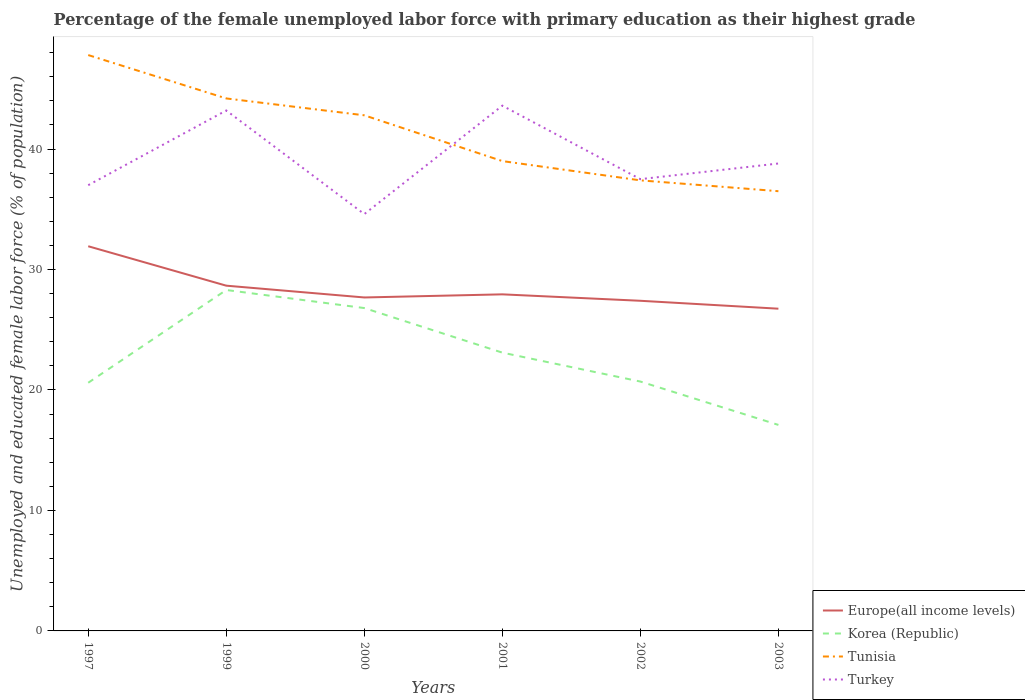How many different coloured lines are there?
Your answer should be compact. 4. Is the number of lines equal to the number of legend labels?
Give a very brief answer. Yes. Across all years, what is the maximum percentage of the unemployed female labor force with primary education in Tunisia?
Your answer should be very brief. 36.5. What is the total percentage of the unemployed female labor force with primary education in Europe(all income levels) in the graph?
Give a very brief answer. 3.27. How many years are there in the graph?
Make the answer very short. 6. Where does the legend appear in the graph?
Provide a succinct answer. Bottom right. How are the legend labels stacked?
Make the answer very short. Vertical. What is the title of the graph?
Ensure brevity in your answer.  Percentage of the female unemployed labor force with primary education as their highest grade. What is the label or title of the Y-axis?
Offer a terse response. Unemployed and educated female labor force (% of population). What is the Unemployed and educated female labor force (% of population) in Europe(all income levels) in 1997?
Your answer should be very brief. 31.93. What is the Unemployed and educated female labor force (% of population) of Korea (Republic) in 1997?
Offer a very short reply. 20.6. What is the Unemployed and educated female labor force (% of population) of Tunisia in 1997?
Offer a very short reply. 47.8. What is the Unemployed and educated female labor force (% of population) of Europe(all income levels) in 1999?
Provide a short and direct response. 28.66. What is the Unemployed and educated female labor force (% of population) in Korea (Republic) in 1999?
Your answer should be compact. 28.3. What is the Unemployed and educated female labor force (% of population) in Tunisia in 1999?
Keep it short and to the point. 44.2. What is the Unemployed and educated female labor force (% of population) of Turkey in 1999?
Offer a terse response. 43.2. What is the Unemployed and educated female labor force (% of population) in Europe(all income levels) in 2000?
Make the answer very short. 27.68. What is the Unemployed and educated female labor force (% of population) of Korea (Republic) in 2000?
Offer a terse response. 26.8. What is the Unemployed and educated female labor force (% of population) of Tunisia in 2000?
Give a very brief answer. 42.8. What is the Unemployed and educated female labor force (% of population) in Turkey in 2000?
Offer a very short reply. 34.6. What is the Unemployed and educated female labor force (% of population) in Europe(all income levels) in 2001?
Offer a terse response. 27.94. What is the Unemployed and educated female labor force (% of population) in Korea (Republic) in 2001?
Provide a short and direct response. 23.1. What is the Unemployed and educated female labor force (% of population) of Turkey in 2001?
Offer a very short reply. 43.6. What is the Unemployed and educated female labor force (% of population) of Europe(all income levels) in 2002?
Your response must be concise. 27.4. What is the Unemployed and educated female labor force (% of population) of Korea (Republic) in 2002?
Ensure brevity in your answer.  20.7. What is the Unemployed and educated female labor force (% of population) of Tunisia in 2002?
Give a very brief answer. 37.4. What is the Unemployed and educated female labor force (% of population) in Turkey in 2002?
Your response must be concise. 37.5. What is the Unemployed and educated female labor force (% of population) in Europe(all income levels) in 2003?
Offer a very short reply. 26.75. What is the Unemployed and educated female labor force (% of population) in Korea (Republic) in 2003?
Make the answer very short. 17.1. What is the Unemployed and educated female labor force (% of population) in Tunisia in 2003?
Offer a very short reply. 36.5. What is the Unemployed and educated female labor force (% of population) of Turkey in 2003?
Ensure brevity in your answer.  38.8. Across all years, what is the maximum Unemployed and educated female labor force (% of population) of Europe(all income levels)?
Offer a very short reply. 31.93. Across all years, what is the maximum Unemployed and educated female labor force (% of population) in Korea (Republic)?
Keep it short and to the point. 28.3. Across all years, what is the maximum Unemployed and educated female labor force (% of population) of Tunisia?
Make the answer very short. 47.8. Across all years, what is the maximum Unemployed and educated female labor force (% of population) of Turkey?
Your answer should be very brief. 43.6. Across all years, what is the minimum Unemployed and educated female labor force (% of population) in Europe(all income levels)?
Offer a terse response. 26.75. Across all years, what is the minimum Unemployed and educated female labor force (% of population) of Korea (Republic)?
Your response must be concise. 17.1. Across all years, what is the minimum Unemployed and educated female labor force (% of population) of Tunisia?
Keep it short and to the point. 36.5. Across all years, what is the minimum Unemployed and educated female labor force (% of population) in Turkey?
Provide a short and direct response. 34.6. What is the total Unemployed and educated female labor force (% of population) in Europe(all income levels) in the graph?
Offer a very short reply. 170.36. What is the total Unemployed and educated female labor force (% of population) in Korea (Republic) in the graph?
Your answer should be compact. 136.6. What is the total Unemployed and educated female labor force (% of population) in Tunisia in the graph?
Give a very brief answer. 247.7. What is the total Unemployed and educated female labor force (% of population) of Turkey in the graph?
Give a very brief answer. 234.7. What is the difference between the Unemployed and educated female labor force (% of population) in Europe(all income levels) in 1997 and that in 1999?
Make the answer very short. 3.27. What is the difference between the Unemployed and educated female labor force (% of population) in Korea (Republic) in 1997 and that in 1999?
Keep it short and to the point. -7.7. What is the difference between the Unemployed and educated female labor force (% of population) in Tunisia in 1997 and that in 1999?
Your answer should be very brief. 3.6. What is the difference between the Unemployed and educated female labor force (% of population) in Europe(all income levels) in 1997 and that in 2000?
Offer a terse response. 4.25. What is the difference between the Unemployed and educated female labor force (% of population) in Korea (Republic) in 1997 and that in 2000?
Give a very brief answer. -6.2. What is the difference between the Unemployed and educated female labor force (% of population) in Turkey in 1997 and that in 2000?
Keep it short and to the point. 2.4. What is the difference between the Unemployed and educated female labor force (% of population) of Europe(all income levels) in 1997 and that in 2001?
Keep it short and to the point. 3.99. What is the difference between the Unemployed and educated female labor force (% of population) in Korea (Republic) in 1997 and that in 2001?
Make the answer very short. -2.5. What is the difference between the Unemployed and educated female labor force (% of population) of Tunisia in 1997 and that in 2001?
Your answer should be compact. 8.8. What is the difference between the Unemployed and educated female labor force (% of population) of Europe(all income levels) in 1997 and that in 2002?
Provide a short and direct response. 4.53. What is the difference between the Unemployed and educated female labor force (% of population) in Turkey in 1997 and that in 2002?
Give a very brief answer. -0.5. What is the difference between the Unemployed and educated female labor force (% of population) of Europe(all income levels) in 1997 and that in 2003?
Your answer should be very brief. 5.18. What is the difference between the Unemployed and educated female labor force (% of population) in Korea (Republic) in 1997 and that in 2003?
Keep it short and to the point. 3.5. What is the difference between the Unemployed and educated female labor force (% of population) of Tunisia in 1997 and that in 2003?
Offer a very short reply. 11.3. What is the difference between the Unemployed and educated female labor force (% of population) of Turkey in 1997 and that in 2003?
Your answer should be very brief. -1.8. What is the difference between the Unemployed and educated female labor force (% of population) in Europe(all income levels) in 1999 and that in 2000?
Make the answer very short. 0.98. What is the difference between the Unemployed and educated female labor force (% of population) in Turkey in 1999 and that in 2000?
Ensure brevity in your answer.  8.6. What is the difference between the Unemployed and educated female labor force (% of population) of Europe(all income levels) in 1999 and that in 2001?
Your answer should be compact. 0.72. What is the difference between the Unemployed and educated female labor force (% of population) in Turkey in 1999 and that in 2001?
Ensure brevity in your answer.  -0.4. What is the difference between the Unemployed and educated female labor force (% of population) in Europe(all income levels) in 1999 and that in 2002?
Your answer should be compact. 1.25. What is the difference between the Unemployed and educated female labor force (% of population) in Korea (Republic) in 1999 and that in 2002?
Your answer should be very brief. 7.6. What is the difference between the Unemployed and educated female labor force (% of population) of Tunisia in 1999 and that in 2002?
Ensure brevity in your answer.  6.8. What is the difference between the Unemployed and educated female labor force (% of population) of Turkey in 1999 and that in 2002?
Make the answer very short. 5.7. What is the difference between the Unemployed and educated female labor force (% of population) in Europe(all income levels) in 1999 and that in 2003?
Ensure brevity in your answer.  1.91. What is the difference between the Unemployed and educated female labor force (% of population) in Korea (Republic) in 1999 and that in 2003?
Your answer should be compact. 11.2. What is the difference between the Unemployed and educated female labor force (% of population) in Turkey in 1999 and that in 2003?
Provide a succinct answer. 4.4. What is the difference between the Unemployed and educated female labor force (% of population) of Europe(all income levels) in 2000 and that in 2001?
Make the answer very short. -0.26. What is the difference between the Unemployed and educated female labor force (% of population) of Korea (Republic) in 2000 and that in 2001?
Make the answer very short. 3.7. What is the difference between the Unemployed and educated female labor force (% of population) of Turkey in 2000 and that in 2001?
Keep it short and to the point. -9. What is the difference between the Unemployed and educated female labor force (% of population) in Europe(all income levels) in 2000 and that in 2002?
Your answer should be compact. 0.28. What is the difference between the Unemployed and educated female labor force (% of population) of Korea (Republic) in 2000 and that in 2002?
Your answer should be compact. 6.1. What is the difference between the Unemployed and educated female labor force (% of population) of Europe(all income levels) in 2000 and that in 2003?
Offer a terse response. 0.93. What is the difference between the Unemployed and educated female labor force (% of population) in Korea (Republic) in 2000 and that in 2003?
Keep it short and to the point. 9.7. What is the difference between the Unemployed and educated female labor force (% of population) of Tunisia in 2000 and that in 2003?
Provide a succinct answer. 6.3. What is the difference between the Unemployed and educated female labor force (% of population) in Europe(all income levels) in 2001 and that in 2002?
Provide a succinct answer. 0.53. What is the difference between the Unemployed and educated female labor force (% of population) in Korea (Republic) in 2001 and that in 2002?
Offer a very short reply. 2.4. What is the difference between the Unemployed and educated female labor force (% of population) of Europe(all income levels) in 2001 and that in 2003?
Your answer should be compact. 1.19. What is the difference between the Unemployed and educated female labor force (% of population) in Europe(all income levels) in 2002 and that in 2003?
Your answer should be compact. 0.66. What is the difference between the Unemployed and educated female labor force (% of population) of Turkey in 2002 and that in 2003?
Your answer should be compact. -1.3. What is the difference between the Unemployed and educated female labor force (% of population) of Europe(all income levels) in 1997 and the Unemployed and educated female labor force (% of population) of Korea (Republic) in 1999?
Offer a terse response. 3.63. What is the difference between the Unemployed and educated female labor force (% of population) of Europe(all income levels) in 1997 and the Unemployed and educated female labor force (% of population) of Tunisia in 1999?
Your answer should be compact. -12.27. What is the difference between the Unemployed and educated female labor force (% of population) in Europe(all income levels) in 1997 and the Unemployed and educated female labor force (% of population) in Turkey in 1999?
Your answer should be very brief. -11.27. What is the difference between the Unemployed and educated female labor force (% of population) in Korea (Republic) in 1997 and the Unemployed and educated female labor force (% of population) in Tunisia in 1999?
Ensure brevity in your answer.  -23.6. What is the difference between the Unemployed and educated female labor force (% of population) in Korea (Republic) in 1997 and the Unemployed and educated female labor force (% of population) in Turkey in 1999?
Ensure brevity in your answer.  -22.6. What is the difference between the Unemployed and educated female labor force (% of population) in Tunisia in 1997 and the Unemployed and educated female labor force (% of population) in Turkey in 1999?
Your answer should be very brief. 4.6. What is the difference between the Unemployed and educated female labor force (% of population) of Europe(all income levels) in 1997 and the Unemployed and educated female labor force (% of population) of Korea (Republic) in 2000?
Keep it short and to the point. 5.13. What is the difference between the Unemployed and educated female labor force (% of population) in Europe(all income levels) in 1997 and the Unemployed and educated female labor force (% of population) in Tunisia in 2000?
Make the answer very short. -10.87. What is the difference between the Unemployed and educated female labor force (% of population) of Europe(all income levels) in 1997 and the Unemployed and educated female labor force (% of population) of Turkey in 2000?
Your response must be concise. -2.67. What is the difference between the Unemployed and educated female labor force (% of population) in Korea (Republic) in 1997 and the Unemployed and educated female labor force (% of population) in Tunisia in 2000?
Your response must be concise. -22.2. What is the difference between the Unemployed and educated female labor force (% of population) of Europe(all income levels) in 1997 and the Unemployed and educated female labor force (% of population) of Korea (Republic) in 2001?
Offer a very short reply. 8.83. What is the difference between the Unemployed and educated female labor force (% of population) in Europe(all income levels) in 1997 and the Unemployed and educated female labor force (% of population) in Tunisia in 2001?
Give a very brief answer. -7.07. What is the difference between the Unemployed and educated female labor force (% of population) in Europe(all income levels) in 1997 and the Unemployed and educated female labor force (% of population) in Turkey in 2001?
Provide a short and direct response. -11.67. What is the difference between the Unemployed and educated female labor force (% of population) in Korea (Republic) in 1997 and the Unemployed and educated female labor force (% of population) in Tunisia in 2001?
Offer a very short reply. -18.4. What is the difference between the Unemployed and educated female labor force (% of population) in Europe(all income levels) in 1997 and the Unemployed and educated female labor force (% of population) in Korea (Republic) in 2002?
Ensure brevity in your answer.  11.23. What is the difference between the Unemployed and educated female labor force (% of population) in Europe(all income levels) in 1997 and the Unemployed and educated female labor force (% of population) in Tunisia in 2002?
Your response must be concise. -5.47. What is the difference between the Unemployed and educated female labor force (% of population) of Europe(all income levels) in 1997 and the Unemployed and educated female labor force (% of population) of Turkey in 2002?
Offer a very short reply. -5.57. What is the difference between the Unemployed and educated female labor force (% of population) in Korea (Republic) in 1997 and the Unemployed and educated female labor force (% of population) in Tunisia in 2002?
Your answer should be compact. -16.8. What is the difference between the Unemployed and educated female labor force (% of population) in Korea (Republic) in 1997 and the Unemployed and educated female labor force (% of population) in Turkey in 2002?
Ensure brevity in your answer.  -16.9. What is the difference between the Unemployed and educated female labor force (% of population) of Europe(all income levels) in 1997 and the Unemployed and educated female labor force (% of population) of Korea (Republic) in 2003?
Give a very brief answer. 14.83. What is the difference between the Unemployed and educated female labor force (% of population) in Europe(all income levels) in 1997 and the Unemployed and educated female labor force (% of population) in Tunisia in 2003?
Offer a terse response. -4.57. What is the difference between the Unemployed and educated female labor force (% of population) in Europe(all income levels) in 1997 and the Unemployed and educated female labor force (% of population) in Turkey in 2003?
Provide a succinct answer. -6.87. What is the difference between the Unemployed and educated female labor force (% of population) in Korea (Republic) in 1997 and the Unemployed and educated female labor force (% of population) in Tunisia in 2003?
Provide a succinct answer. -15.9. What is the difference between the Unemployed and educated female labor force (% of population) of Korea (Republic) in 1997 and the Unemployed and educated female labor force (% of population) of Turkey in 2003?
Provide a succinct answer. -18.2. What is the difference between the Unemployed and educated female labor force (% of population) of Tunisia in 1997 and the Unemployed and educated female labor force (% of population) of Turkey in 2003?
Provide a short and direct response. 9. What is the difference between the Unemployed and educated female labor force (% of population) of Europe(all income levels) in 1999 and the Unemployed and educated female labor force (% of population) of Korea (Republic) in 2000?
Offer a terse response. 1.86. What is the difference between the Unemployed and educated female labor force (% of population) in Europe(all income levels) in 1999 and the Unemployed and educated female labor force (% of population) in Tunisia in 2000?
Make the answer very short. -14.14. What is the difference between the Unemployed and educated female labor force (% of population) of Europe(all income levels) in 1999 and the Unemployed and educated female labor force (% of population) of Turkey in 2000?
Make the answer very short. -5.94. What is the difference between the Unemployed and educated female labor force (% of population) in Europe(all income levels) in 1999 and the Unemployed and educated female labor force (% of population) in Korea (Republic) in 2001?
Offer a terse response. 5.56. What is the difference between the Unemployed and educated female labor force (% of population) in Europe(all income levels) in 1999 and the Unemployed and educated female labor force (% of population) in Tunisia in 2001?
Make the answer very short. -10.34. What is the difference between the Unemployed and educated female labor force (% of population) of Europe(all income levels) in 1999 and the Unemployed and educated female labor force (% of population) of Turkey in 2001?
Give a very brief answer. -14.94. What is the difference between the Unemployed and educated female labor force (% of population) in Korea (Republic) in 1999 and the Unemployed and educated female labor force (% of population) in Turkey in 2001?
Provide a succinct answer. -15.3. What is the difference between the Unemployed and educated female labor force (% of population) of Europe(all income levels) in 1999 and the Unemployed and educated female labor force (% of population) of Korea (Republic) in 2002?
Your answer should be very brief. 7.96. What is the difference between the Unemployed and educated female labor force (% of population) of Europe(all income levels) in 1999 and the Unemployed and educated female labor force (% of population) of Tunisia in 2002?
Your answer should be very brief. -8.74. What is the difference between the Unemployed and educated female labor force (% of population) of Europe(all income levels) in 1999 and the Unemployed and educated female labor force (% of population) of Turkey in 2002?
Give a very brief answer. -8.84. What is the difference between the Unemployed and educated female labor force (% of population) in Korea (Republic) in 1999 and the Unemployed and educated female labor force (% of population) in Tunisia in 2002?
Give a very brief answer. -9.1. What is the difference between the Unemployed and educated female labor force (% of population) of Europe(all income levels) in 1999 and the Unemployed and educated female labor force (% of population) of Korea (Republic) in 2003?
Offer a terse response. 11.56. What is the difference between the Unemployed and educated female labor force (% of population) in Europe(all income levels) in 1999 and the Unemployed and educated female labor force (% of population) in Tunisia in 2003?
Provide a short and direct response. -7.84. What is the difference between the Unemployed and educated female labor force (% of population) in Europe(all income levels) in 1999 and the Unemployed and educated female labor force (% of population) in Turkey in 2003?
Provide a short and direct response. -10.14. What is the difference between the Unemployed and educated female labor force (% of population) in Korea (Republic) in 1999 and the Unemployed and educated female labor force (% of population) in Turkey in 2003?
Provide a succinct answer. -10.5. What is the difference between the Unemployed and educated female labor force (% of population) of Tunisia in 1999 and the Unemployed and educated female labor force (% of population) of Turkey in 2003?
Provide a short and direct response. 5.4. What is the difference between the Unemployed and educated female labor force (% of population) in Europe(all income levels) in 2000 and the Unemployed and educated female labor force (% of population) in Korea (Republic) in 2001?
Offer a terse response. 4.58. What is the difference between the Unemployed and educated female labor force (% of population) of Europe(all income levels) in 2000 and the Unemployed and educated female labor force (% of population) of Tunisia in 2001?
Ensure brevity in your answer.  -11.32. What is the difference between the Unemployed and educated female labor force (% of population) of Europe(all income levels) in 2000 and the Unemployed and educated female labor force (% of population) of Turkey in 2001?
Provide a short and direct response. -15.92. What is the difference between the Unemployed and educated female labor force (% of population) in Korea (Republic) in 2000 and the Unemployed and educated female labor force (% of population) in Tunisia in 2001?
Your response must be concise. -12.2. What is the difference between the Unemployed and educated female labor force (% of population) in Korea (Republic) in 2000 and the Unemployed and educated female labor force (% of population) in Turkey in 2001?
Your answer should be compact. -16.8. What is the difference between the Unemployed and educated female labor force (% of population) of Tunisia in 2000 and the Unemployed and educated female labor force (% of population) of Turkey in 2001?
Your answer should be compact. -0.8. What is the difference between the Unemployed and educated female labor force (% of population) of Europe(all income levels) in 2000 and the Unemployed and educated female labor force (% of population) of Korea (Republic) in 2002?
Your answer should be compact. 6.98. What is the difference between the Unemployed and educated female labor force (% of population) of Europe(all income levels) in 2000 and the Unemployed and educated female labor force (% of population) of Tunisia in 2002?
Give a very brief answer. -9.72. What is the difference between the Unemployed and educated female labor force (% of population) of Europe(all income levels) in 2000 and the Unemployed and educated female labor force (% of population) of Turkey in 2002?
Your response must be concise. -9.82. What is the difference between the Unemployed and educated female labor force (% of population) of Korea (Republic) in 2000 and the Unemployed and educated female labor force (% of population) of Turkey in 2002?
Your response must be concise. -10.7. What is the difference between the Unemployed and educated female labor force (% of population) of Tunisia in 2000 and the Unemployed and educated female labor force (% of population) of Turkey in 2002?
Make the answer very short. 5.3. What is the difference between the Unemployed and educated female labor force (% of population) of Europe(all income levels) in 2000 and the Unemployed and educated female labor force (% of population) of Korea (Republic) in 2003?
Provide a short and direct response. 10.58. What is the difference between the Unemployed and educated female labor force (% of population) of Europe(all income levels) in 2000 and the Unemployed and educated female labor force (% of population) of Tunisia in 2003?
Your answer should be very brief. -8.82. What is the difference between the Unemployed and educated female labor force (% of population) of Europe(all income levels) in 2000 and the Unemployed and educated female labor force (% of population) of Turkey in 2003?
Your response must be concise. -11.12. What is the difference between the Unemployed and educated female labor force (% of population) in Korea (Republic) in 2000 and the Unemployed and educated female labor force (% of population) in Turkey in 2003?
Keep it short and to the point. -12. What is the difference between the Unemployed and educated female labor force (% of population) of Europe(all income levels) in 2001 and the Unemployed and educated female labor force (% of population) of Korea (Republic) in 2002?
Give a very brief answer. 7.24. What is the difference between the Unemployed and educated female labor force (% of population) of Europe(all income levels) in 2001 and the Unemployed and educated female labor force (% of population) of Tunisia in 2002?
Your answer should be very brief. -9.46. What is the difference between the Unemployed and educated female labor force (% of population) of Europe(all income levels) in 2001 and the Unemployed and educated female labor force (% of population) of Turkey in 2002?
Provide a short and direct response. -9.56. What is the difference between the Unemployed and educated female labor force (% of population) in Korea (Republic) in 2001 and the Unemployed and educated female labor force (% of population) in Tunisia in 2002?
Your answer should be very brief. -14.3. What is the difference between the Unemployed and educated female labor force (% of population) in Korea (Republic) in 2001 and the Unemployed and educated female labor force (% of population) in Turkey in 2002?
Give a very brief answer. -14.4. What is the difference between the Unemployed and educated female labor force (% of population) of Europe(all income levels) in 2001 and the Unemployed and educated female labor force (% of population) of Korea (Republic) in 2003?
Provide a succinct answer. 10.84. What is the difference between the Unemployed and educated female labor force (% of population) of Europe(all income levels) in 2001 and the Unemployed and educated female labor force (% of population) of Tunisia in 2003?
Provide a succinct answer. -8.56. What is the difference between the Unemployed and educated female labor force (% of population) in Europe(all income levels) in 2001 and the Unemployed and educated female labor force (% of population) in Turkey in 2003?
Provide a succinct answer. -10.86. What is the difference between the Unemployed and educated female labor force (% of population) of Korea (Republic) in 2001 and the Unemployed and educated female labor force (% of population) of Tunisia in 2003?
Offer a very short reply. -13.4. What is the difference between the Unemployed and educated female labor force (% of population) of Korea (Republic) in 2001 and the Unemployed and educated female labor force (% of population) of Turkey in 2003?
Make the answer very short. -15.7. What is the difference between the Unemployed and educated female labor force (% of population) of Tunisia in 2001 and the Unemployed and educated female labor force (% of population) of Turkey in 2003?
Make the answer very short. 0.2. What is the difference between the Unemployed and educated female labor force (% of population) of Europe(all income levels) in 2002 and the Unemployed and educated female labor force (% of population) of Korea (Republic) in 2003?
Provide a short and direct response. 10.3. What is the difference between the Unemployed and educated female labor force (% of population) of Europe(all income levels) in 2002 and the Unemployed and educated female labor force (% of population) of Tunisia in 2003?
Keep it short and to the point. -9.1. What is the difference between the Unemployed and educated female labor force (% of population) of Europe(all income levels) in 2002 and the Unemployed and educated female labor force (% of population) of Turkey in 2003?
Offer a very short reply. -11.4. What is the difference between the Unemployed and educated female labor force (% of population) in Korea (Republic) in 2002 and the Unemployed and educated female labor force (% of population) in Tunisia in 2003?
Provide a short and direct response. -15.8. What is the difference between the Unemployed and educated female labor force (% of population) of Korea (Republic) in 2002 and the Unemployed and educated female labor force (% of population) of Turkey in 2003?
Your answer should be very brief. -18.1. What is the average Unemployed and educated female labor force (% of population) in Europe(all income levels) per year?
Give a very brief answer. 28.39. What is the average Unemployed and educated female labor force (% of population) of Korea (Republic) per year?
Ensure brevity in your answer.  22.77. What is the average Unemployed and educated female labor force (% of population) of Tunisia per year?
Offer a terse response. 41.28. What is the average Unemployed and educated female labor force (% of population) of Turkey per year?
Your answer should be compact. 39.12. In the year 1997, what is the difference between the Unemployed and educated female labor force (% of population) of Europe(all income levels) and Unemployed and educated female labor force (% of population) of Korea (Republic)?
Make the answer very short. 11.33. In the year 1997, what is the difference between the Unemployed and educated female labor force (% of population) of Europe(all income levels) and Unemployed and educated female labor force (% of population) of Tunisia?
Provide a short and direct response. -15.87. In the year 1997, what is the difference between the Unemployed and educated female labor force (% of population) of Europe(all income levels) and Unemployed and educated female labor force (% of population) of Turkey?
Your answer should be very brief. -5.07. In the year 1997, what is the difference between the Unemployed and educated female labor force (% of population) in Korea (Republic) and Unemployed and educated female labor force (% of population) in Tunisia?
Give a very brief answer. -27.2. In the year 1997, what is the difference between the Unemployed and educated female labor force (% of population) of Korea (Republic) and Unemployed and educated female labor force (% of population) of Turkey?
Ensure brevity in your answer.  -16.4. In the year 1999, what is the difference between the Unemployed and educated female labor force (% of population) in Europe(all income levels) and Unemployed and educated female labor force (% of population) in Korea (Republic)?
Offer a very short reply. 0.36. In the year 1999, what is the difference between the Unemployed and educated female labor force (% of population) of Europe(all income levels) and Unemployed and educated female labor force (% of population) of Tunisia?
Ensure brevity in your answer.  -15.54. In the year 1999, what is the difference between the Unemployed and educated female labor force (% of population) in Europe(all income levels) and Unemployed and educated female labor force (% of population) in Turkey?
Make the answer very short. -14.54. In the year 1999, what is the difference between the Unemployed and educated female labor force (% of population) in Korea (Republic) and Unemployed and educated female labor force (% of population) in Tunisia?
Offer a very short reply. -15.9. In the year 1999, what is the difference between the Unemployed and educated female labor force (% of population) in Korea (Republic) and Unemployed and educated female labor force (% of population) in Turkey?
Provide a short and direct response. -14.9. In the year 2000, what is the difference between the Unemployed and educated female labor force (% of population) of Europe(all income levels) and Unemployed and educated female labor force (% of population) of Korea (Republic)?
Offer a terse response. 0.88. In the year 2000, what is the difference between the Unemployed and educated female labor force (% of population) in Europe(all income levels) and Unemployed and educated female labor force (% of population) in Tunisia?
Offer a very short reply. -15.12. In the year 2000, what is the difference between the Unemployed and educated female labor force (% of population) of Europe(all income levels) and Unemployed and educated female labor force (% of population) of Turkey?
Provide a short and direct response. -6.92. In the year 2000, what is the difference between the Unemployed and educated female labor force (% of population) in Korea (Republic) and Unemployed and educated female labor force (% of population) in Turkey?
Keep it short and to the point. -7.8. In the year 2001, what is the difference between the Unemployed and educated female labor force (% of population) of Europe(all income levels) and Unemployed and educated female labor force (% of population) of Korea (Republic)?
Keep it short and to the point. 4.84. In the year 2001, what is the difference between the Unemployed and educated female labor force (% of population) of Europe(all income levels) and Unemployed and educated female labor force (% of population) of Tunisia?
Give a very brief answer. -11.06. In the year 2001, what is the difference between the Unemployed and educated female labor force (% of population) of Europe(all income levels) and Unemployed and educated female labor force (% of population) of Turkey?
Keep it short and to the point. -15.66. In the year 2001, what is the difference between the Unemployed and educated female labor force (% of population) in Korea (Republic) and Unemployed and educated female labor force (% of population) in Tunisia?
Ensure brevity in your answer.  -15.9. In the year 2001, what is the difference between the Unemployed and educated female labor force (% of population) in Korea (Republic) and Unemployed and educated female labor force (% of population) in Turkey?
Your response must be concise. -20.5. In the year 2001, what is the difference between the Unemployed and educated female labor force (% of population) of Tunisia and Unemployed and educated female labor force (% of population) of Turkey?
Keep it short and to the point. -4.6. In the year 2002, what is the difference between the Unemployed and educated female labor force (% of population) of Europe(all income levels) and Unemployed and educated female labor force (% of population) of Korea (Republic)?
Your answer should be compact. 6.7. In the year 2002, what is the difference between the Unemployed and educated female labor force (% of population) in Europe(all income levels) and Unemployed and educated female labor force (% of population) in Tunisia?
Your answer should be compact. -10. In the year 2002, what is the difference between the Unemployed and educated female labor force (% of population) in Europe(all income levels) and Unemployed and educated female labor force (% of population) in Turkey?
Ensure brevity in your answer.  -10.1. In the year 2002, what is the difference between the Unemployed and educated female labor force (% of population) in Korea (Republic) and Unemployed and educated female labor force (% of population) in Tunisia?
Offer a very short reply. -16.7. In the year 2002, what is the difference between the Unemployed and educated female labor force (% of population) of Korea (Republic) and Unemployed and educated female labor force (% of population) of Turkey?
Provide a short and direct response. -16.8. In the year 2003, what is the difference between the Unemployed and educated female labor force (% of population) of Europe(all income levels) and Unemployed and educated female labor force (% of population) of Korea (Republic)?
Your answer should be compact. 9.65. In the year 2003, what is the difference between the Unemployed and educated female labor force (% of population) in Europe(all income levels) and Unemployed and educated female labor force (% of population) in Tunisia?
Your answer should be very brief. -9.75. In the year 2003, what is the difference between the Unemployed and educated female labor force (% of population) of Europe(all income levels) and Unemployed and educated female labor force (% of population) of Turkey?
Offer a terse response. -12.05. In the year 2003, what is the difference between the Unemployed and educated female labor force (% of population) of Korea (Republic) and Unemployed and educated female labor force (% of population) of Tunisia?
Your answer should be compact. -19.4. In the year 2003, what is the difference between the Unemployed and educated female labor force (% of population) in Korea (Republic) and Unemployed and educated female labor force (% of population) in Turkey?
Offer a terse response. -21.7. In the year 2003, what is the difference between the Unemployed and educated female labor force (% of population) of Tunisia and Unemployed and educated female labor force (% of population) of Turkey?
Offer a terse response. -2.3. What is the ratio of the Unemployed and educated female labor force (% of population) in Europe(all income levels) in 1997 to that in 1999?
Provide a succinct answer. 1.11. What is the ratio of the Unemployed and educated female labor force (% of population) of Korea (Republic) in 1997 to that in 1999?
Keep it short and to the point. 0.73. What is the ratio of the Unemployed and educated female labor force (% of population) in Tunisia in 1997 to that in 1999?
Make the answer very short. 1.08. What is the ratio of the Unemployed and educated female labor force (% of population) in Turkey in 1997 to that in 1999?
Provide a short and direct response. 0.86. What is the ratio of the Unemployed and educated female labor force (% of population) of Europe(all income levels) in 1997 to that in 2000?
Your response must be concise. 1.15. What is the ratio of the Unemployed and educated female labor force (% of population) of Korea (Republic) in 1997 to that in 2000?
Keep it short and to the point. 0.77. What is the ratio of the Unemployed and educated female labor force (% of population) of Tunisia in 1997 to that in 2000?
Your answer should be very brief. 1.12. What is the ratio of the Unemployed and educated female labor force (% of population) in Turkey in 1997 to that in 2000?
Your response must be concise. 1.07. What is the ratio of the Unemployed and educated female labor force (% of population) of Korea (Republic) in 1997 to that in 2001?
Keep it short and to the point. 0.89. What is the ratio of the Unemployed and educated female labor force (% of population) of Tunisia in 1997 to that in 2001?
Give a very brief answer. 1.23. What is the ratio of the Unemployed and educated female labor force (% of population) in Turkey in 1997 to that in 2001?
Offer a terse response. 0.85. What is the ratio of the Unemployed and educated female labor force (% of population) of Europe(all income levels) in 1997 to that in 2002?
Ensure brevity in your answer.  1.17. What is the ratio of the Unemployed and educated female labor force (% of population) in Tunisia in 1997 to that in 2002?
Provide a short and direct response. 1.28. What is the ratio of the Unemployed and educated female labor force (% of population) in Turkey in 1997 to that in 2002?
Ensure brevity in your answer.  0.99. What is the ratio of the Unemployed and educated female labor force (% of population) of Europe(all income levels) in 1997 to that in 2003?
Provide a succinct answer. 1.19. What is the ratio of the Unemployed and educated female labor force (% of population) in Korea (Republic) in 1997 to that in 2003?
Make the answer very short. 1.2. What is the ratio of the Unemployed and educated female labor force (% of population) in Tunisia in 1997 to that in 2003?
Offer a terse response. 1.31. What is the ratio of the Unemployed and educated female labor force (% of population) in Turkey in 1997 to that in 2003?
Your answer should be very brief. 0.95. What is the ratio of the Unemployed and educated female labor force (% of population) of Europe(all income levels) in 1999 to that in 2000?
Your answer should be compact. 1.04. What is the ratio of the Unemployed and educated female labor force (% of population) in Korea (Republic) in 1999 to that in 2000?
Provide a succinct answer. 1.06. What is the ratio of the Unemployed and educated female labor force (% of population) in Tunisia in 1999 to that in 2000?
Keep it short and to the point. 1.03. What is the ratio of the Unemployed and educated female labor force (% of population) in Turkey in 1999 to that in 2000?
Your response must be concise. 1.25. What is the ratio of the Unemployed and educated female labor force (% of population) of Europe(all income levels) in 1999 to that in 2001?
Give a very brief answer. 1.03. What is the ratio of the Unemployed and educated female labor force (% of population) of Korea (Republic) in 1999 to that in 2001?
Your answer should be compact. 1.23. What is the ratio of the Unemployed and educated female labor force (% of population) in Tunisia in 1999 to that in 2001?
Offer a terse response. 1.13. What is the ratio of the Unemployed and educated female labor force (% of population) in Europe(all income levels) in 1999 to that in 2002?
Provide a succinct answer. 1.05. What is the ratio of the Unemployed and educated female labor force (% of population) of Korea (Republic) in 1999 to that in 2002?
Your answer should be very brief. 1.37. What is the ratio of the Unemployed and educated female labor force (% of population) of Tunisia in 1999 to that in 2002?
Offer a terse response. 1.18. What is the ratio of the Unemployed and educated female labor force (% of population) in Turkey in 1999 to that in 2002?
Give a very brief answer. 1.15. What is the ratio of the Unemployed and educated female labor force (% of population) in Europe(all income levels) in 1999 to that in 2003?
Offer a terse response. 1.07. What is the ratio of the Unemployed and educated female labor force (% of population) in Korea (Republic) in 1999 to that in 2003?
Keep it short and to the point. 1.66. What is the ratio of the Unemployed and educated female labor force (% of population) of Tunisia in 1999 to that in 2003?
Offer a very short reply. 1.21. What is the ratio of the Unemployed and educated female labor force (% of population) in Turkey in 1999 to that in 2003?
Offer a terse response. 1.11. What is the ratio of the Unemployed and educated female labor force (% of population) in Europe(all income levels) in 2000 to that in 2001?
Provide a succinct answer. 0.99. What is the ratio of the Unemployed and educated female labor force (% of population) in Korea (Republic) in 2000 to that in 2001?
Make the answer very short. 1.16. What is the ratio of the Unemployed and educated female labor force (% of population) of Tunisia in 2000 to that in 2001?
Provide a short and direct response. 1.1. What is the ratio of the Unemployed and educated female labor force (% of population) in Turkey in 2000 to that in 2001?
Make the answer very short. 0.79. What is the ratio of the Unemployed and educated female labor force (% of population) in Korea (Republic) in 2000 to that in 2002?
Your response must be concise. 1.29. What is the ratio of the Unemployed and educated female labor force (% of population) in Tunisia in 2000 to that in 2002?
Give a very brief answer. 1.14. What is the ratio of the Unemployed and educated female labor force (% of population) in Turkey in 2000 to that in 2002?
Provide a succinct answer. 0.92. What is the ratio of the Unemployed and educated female labor force (% of population) in Europe(all income levels) in 2000 to that in 2003?
Offer a terse response. 1.03. What is the ratio of the Unemployed and educated female labor force (% of population) of Korea (Republic) in 2000 to that in 2003?
Ensure brevity in your answer.  1.57. What is the ratio of the Unemployed and educated female labor force (% of population) of Tunisia in 2000 to that in 2003?
Your answer should be compact. 1.17. What is the ratio of the Unemployed and educated female labor force (% of population) of Turkey in 2000 to that in 2003?
Keep it short and to the point. 0.89. What is the ratio of the Unemployed and educated female labor force (% of population) in Europe(all income levels) in 2001 to that in 2002?
Provide a short and direct response. 1.02. What is the ratio of the Unemployed and educated female labor force (% of population) of Korea (Republic) in 2001 to that in 2002?
Your answer should be compact. 1.12. What is the ratio of the Unemployed and educated female labor force (% of population) in Tunisia in 2001 to that in 2002?
Offer a very short reply. 1.04. What is the ratio of the Unemployed and educated female labor force (% of population) of Turkey in 2001 to that in 2002?
Your response must be concise. 1.16. What is the ratio of the Unemployed and educated female labor force (% of population) in Europe(all income levels) in 2001 to that in 2003?
Your response must be concise. 1.04. What is the ratio of the Unemployed and educated female labor force (% of population) in Korea (Republic) in 2001 to that in 2003?
Your answer should be compact. 1.35. What is the ratio of the Unemployed and educated female labor force (% of population) of Tunisia in 2001 to that in 2003?
Provide a short and direct response. 1.07. What is the ratio of the Unemployed and educated female labor force (% of population) of Turkey in 2001 to that in 2003?
Provide a short and direct response. 1.12. What is the ratio of the Unemployed and educated female labor force (% of population) in Europe(all income levels) in 2002 to that in 2003?
Offer a terse response. 1.02. What is the ratio of the Unemployed and educated female labor force (% of population) in Korea (Republic) in 2002 to that in 2003?
Provide a short and direct response. 1.21. What is the ratio of the Unemployed and educated female labor force (% of population) in Tunisia in 2002 to that in 2003?
Ensure brevity in your answer.  1.02. What is the ratio of the Unemployed and educated female labor force (% of population) of Turkey in 2002 to that in 2003?
Make the answer very short. 0.97. What is the difference between the highest and the second highest Unemployed and educated female labor force (% of population) of Europe(all income levels)?
Give a very brief answer. 3.27. What is the difference between the highest and the lowest Unemployed and educated female labor force (% of population) in Europe(all income levels)?
Ensure brevity in your answer.  5.18. What is the difference between the highest and the lowest Unemployed and educated female labor force (% of population) in Tunisia?
Ensure brevity in your answer.  11.3. What is the difference between the highest and the lowest Unemployed and educated female labor force (% of population) of Turkey?
Make the answer very short. 9. 